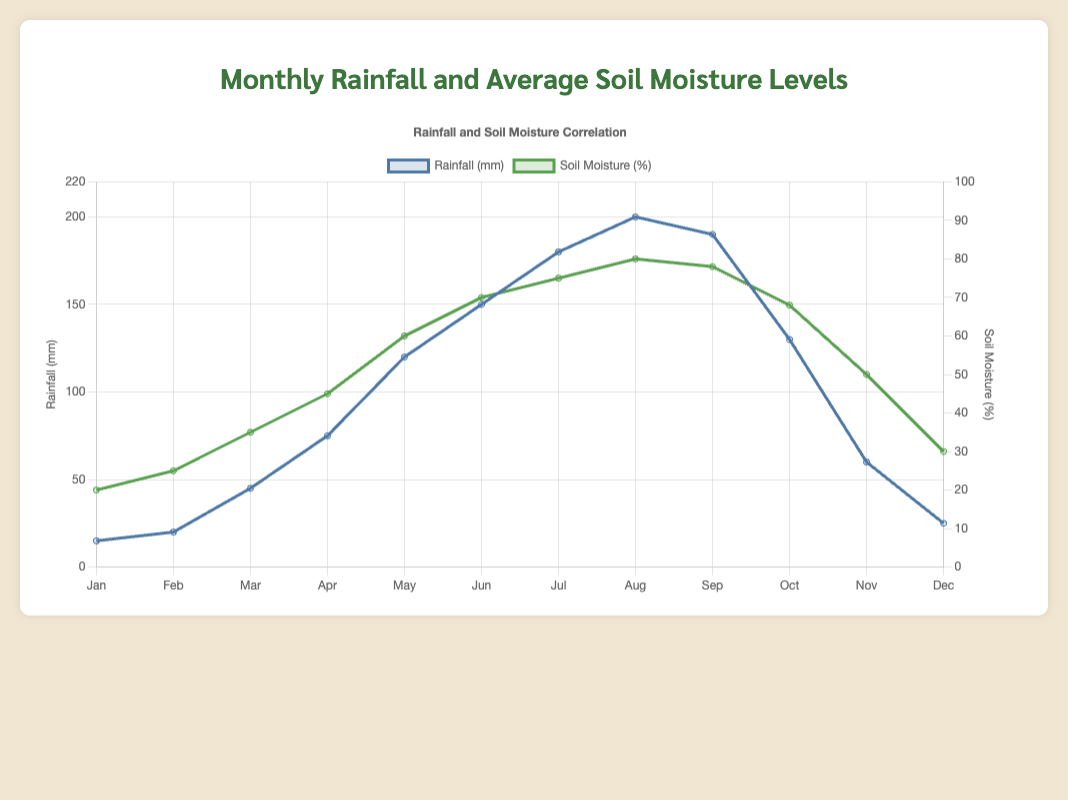What was the rainfall in March? To find the rainfall in March, look at the data line labeled "Rainfall (mm)" at the point corresponding to "Mar". The line reaches up to 45 mm.
Answer: 45 mm Which month had the highest soil moisture level? To determine the month with the highest soil moisture, identify the peak of the data line labeled "Soil Moisture (%)". The highest point is reached in August, corresponding to 80%.
Answer: August How much did the soil moisture percentage increase from January to May? First, find the soil moisture in January (20%) and May (60%). Calculate the difference between these values: 60% - 20% = 40%.
Answer: 40% Compare the rainfall in June and July. Which month had more rainfall? To compare, look at the data points for "Rainfall (mm)" in June and July. June shows 150 mm, and July shows 180 mm. July had more rainfall.
Answer: July What is the average soil moisture percentage for the first half of the year (January to June)? Consider the data points for January (20%), February (25%), March (35%), April (45%), May (60%), and June (70%). Calculate the average: (20% + 25% + 35% + 45% + 60% + 70%) / 6 = 42.5%.
Answer: 42.5% Is there a month where the soil moisture level decreased compared to the previous month? If so, which month? Observe the trend of the soil moisture line. The soil moisture decreases from August (80%) to September (78%) and then again from September to October (68%). The month of decline following a peak is September.
Answer: September What is the difference in rainfall between the wettest and driest months? Identify the months with the highest and lowest rainfall. August has the highest rainfall (200 mm), and January has the lowest (15 mm). The difference is 200 mm - 15 mm = 185 mm.
Answer: 185 mm How does the soil moisture percentage in October compare to November? Find the soil moisture levels for October (68%) and November (50%). October has a higher soil moisture percentage than November.
Answer: October has higher soil moisture Did the rainfall increase every month from January to August? Check the "Rainfall (mm)" data points from January to August. The values continuously increase from 15 mm to 200 mm without any decrease.
Answer: Yes Which month had the closest soil moisture level to the average soil moisture level for the whole year? First, calculate the average soil moisture for the year: (20% + 25% + 35% + 45% + 60% + 70% + 75% + 80% + 78% + 68% + 50% + 30%) / 12 = 52.5%. The closest month to this average is November (50%).
Answer: November 